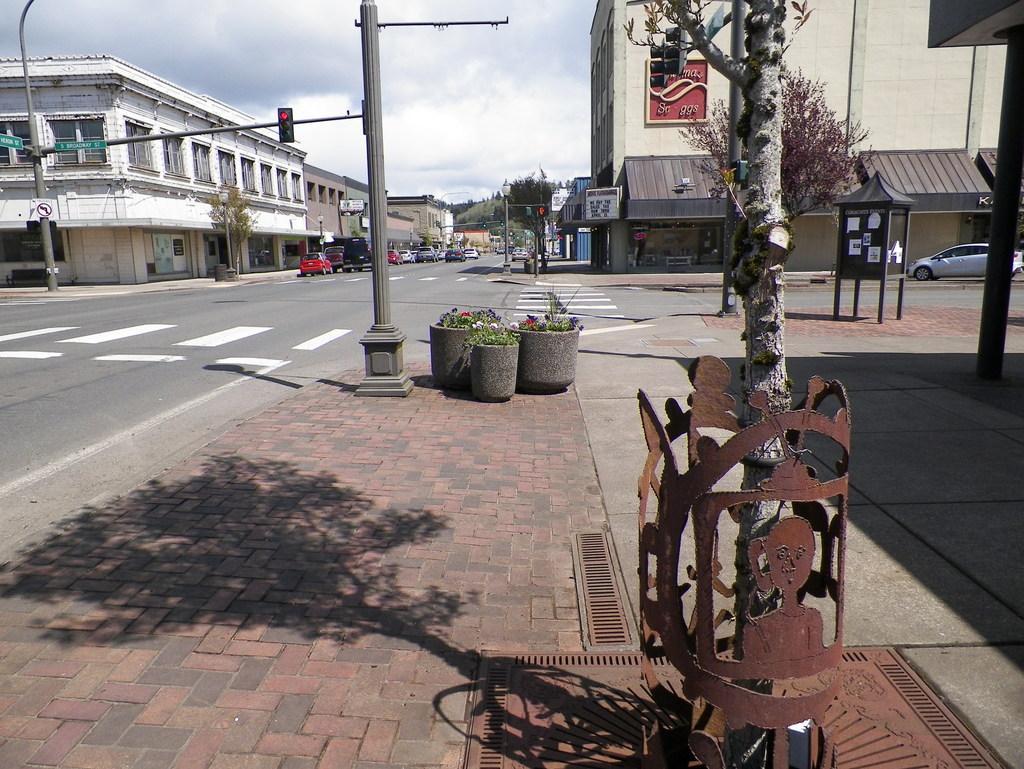Could you give a brief overview of what you see in this image? In this image we can see the buildings, some roads, some trees, some poles, some vehicles on the roads, few boards with poles, one signal light with pole, few objects with poles, some posters attached to the object on the footpath, few plants with flowers in the pots on the footpath, one fence around the tree on the footpath, few objects in the buildings, few objects attached to the buildings and at the top there is the sky. 